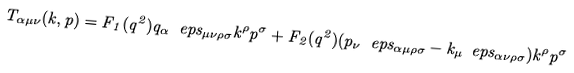<formula> <loc_0><loc_0><loc_500><loc_500>T _ { \alpha \mu \nu } ( k , p ) = F _ { 1 } ( q ^ { 2 } ) q _ { \alpha } \ e p s _ { \mu \nu \rho \sigma } k ^ { \rho } p ^ { \sigma } + F _ { 2 } ( q ^ { 2 } ) ( p _ { \nu } \ e p s _ { \alpha \mu \rho \sigma } - k _ { \mu } \ e p s _ { \alpha \nu \rho \sigma } ) k ^ { \rho } p ^ { \sigma }</formula> 